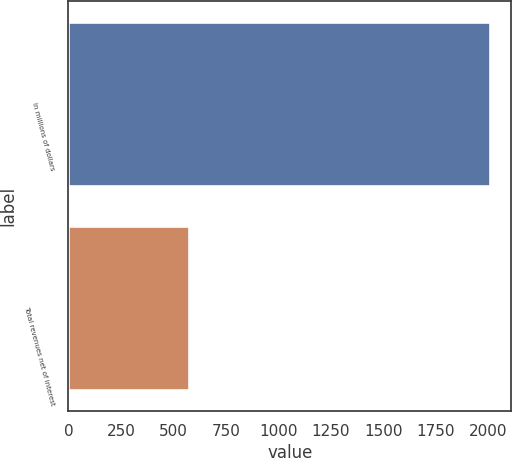<chart> <loc_0><loc_0><loc_500><loc_500><bar_chart><fcel>In millions of dollars<fcel>Total revenues net of interest<nl><fcel>2010<fcel>577<nl></chart> 